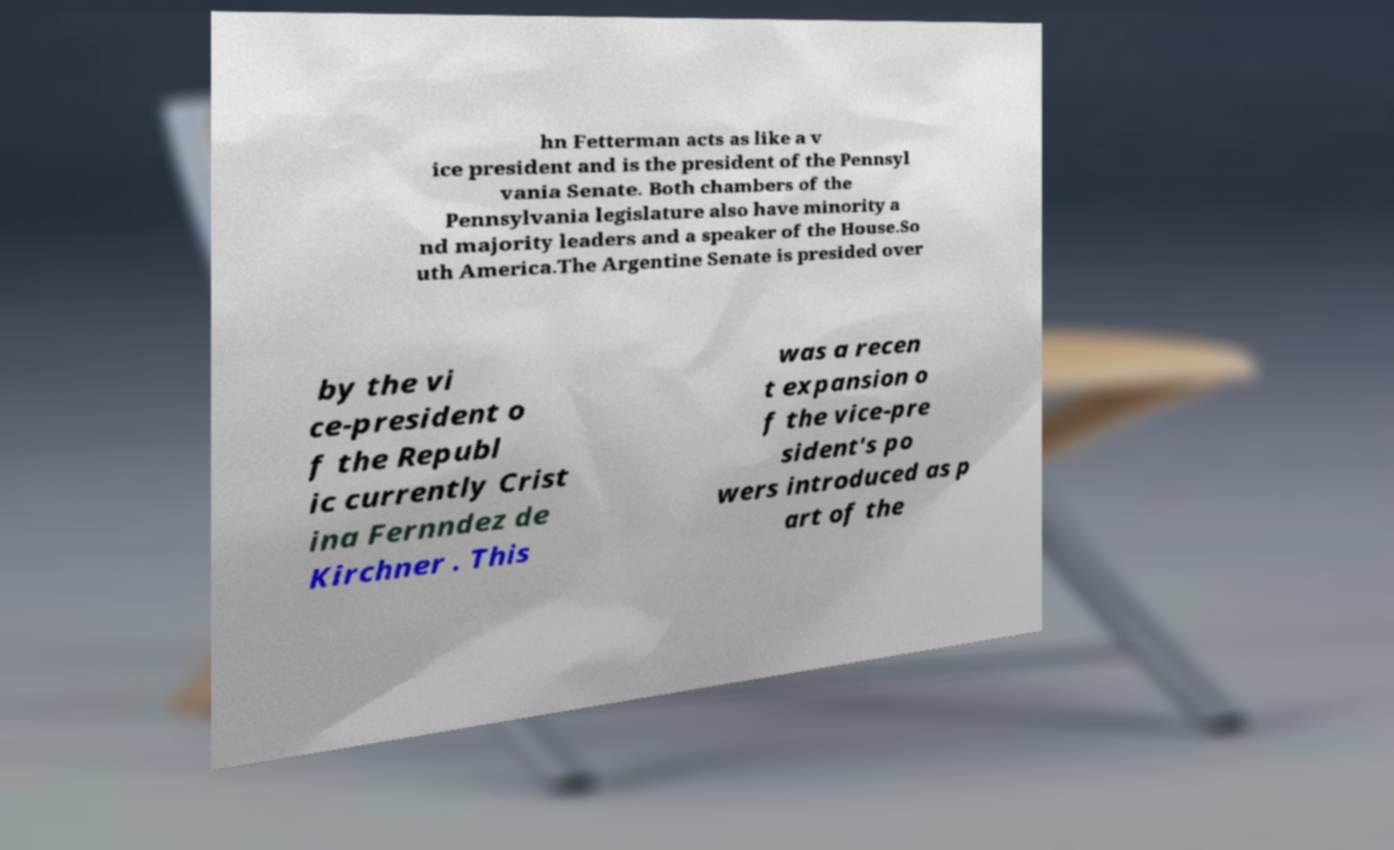What messages or text are displayed in this image? I need them in a readable, typed format. hn Fetterman acts as like a v ice president and is the president of the Pennsyl vania Senate. Both chambers of the Pennsylvania legislature also have minority a nd majority leaders and a speaker of the House.So uth America.The Argentine Senate is presided over by the vi ce-president o f the Republ ic currently Crist ina Fernndez de Kirchner . This was a recen t expansion o f the vice-pre sident's po wers introduced as p art of the 